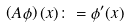Convert formula to latex. <formula><loc_0><loc_0><loc_500><loc_500>\left ( A \phi \right ) ( x ) \colon = \phi ^ { \prime } ( x )</formula> 